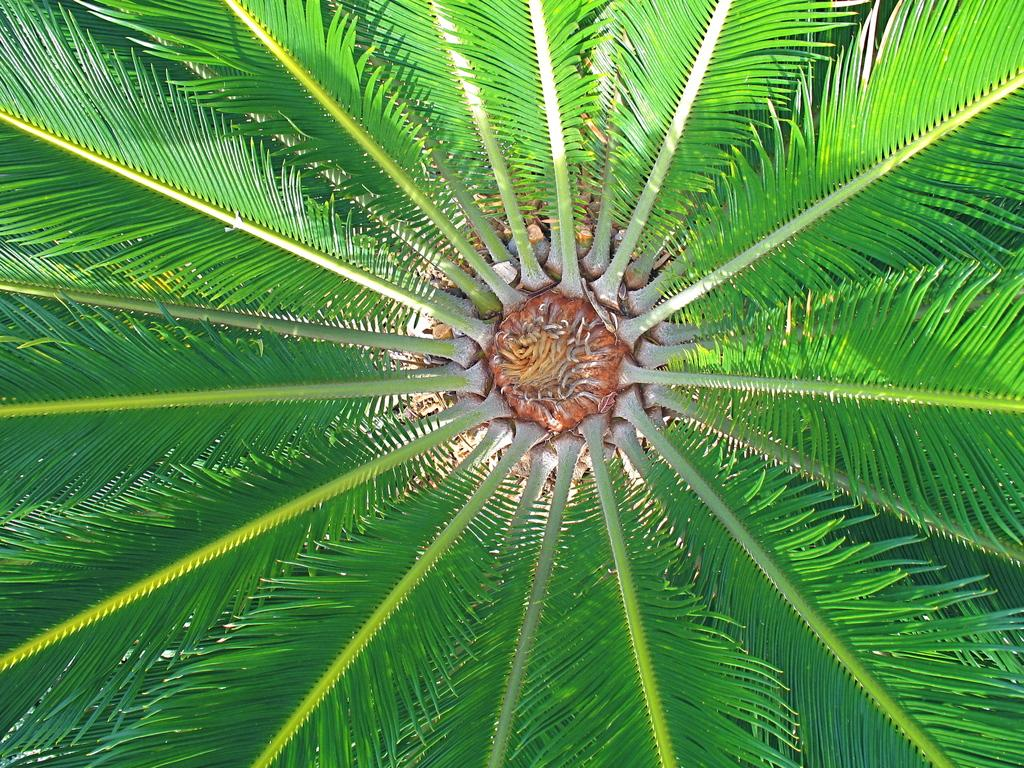What type of tree is depicted in the image? The image features branches of a coconut tree. Can you describe the appearance of the tree's branches? The branches of the coconut tree are visible in the image. Are there any dinosaurs visible in the image? No, there are no dinosaurs present in the image; it features branches of a coconut tree. What type of terrain is visible in the image? The image does not show any terrain, as it only features branches of a coconut tree. 